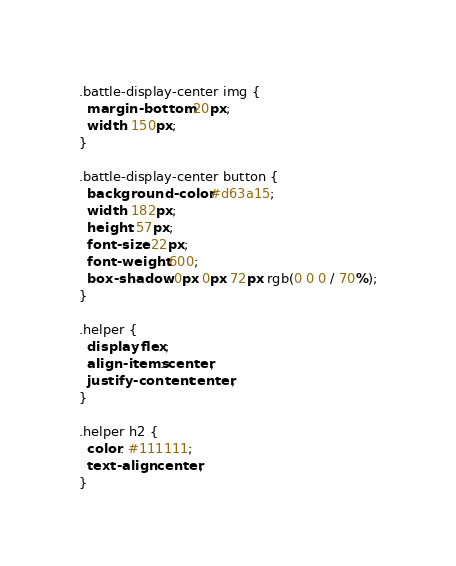<code> <loc_0><loc_0><loc_500><loc_500><_CSS_>.battle-display-center img {
  margin-bottom: 20px;
  width: 150px;
}

.battle-display-center button {
  background-color: #d63a15;
  width: 182px;
  height: 57px;
  font-size: 22px;
  font-weight: 600;
  box-shadow: 0px 0px 72px rgb(0 0 0 / 70%);
}

.helper {
  display: flex;
  align-items: center;
  justify-content: center;
}

.helper h2 {
  color: #111111;
  text-align: center;
}
</code> 